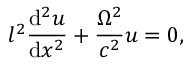Convert formula to latex. <formula><loc_0><loc_0><loc_500><loc_500>l ^ { 2 } \frac { d ^ { 2 } u } { d x ^ { 2 } } + \frac { \Omega ^ { 2 } } { c ^ { 2 } } u = 0 ,</formula> 